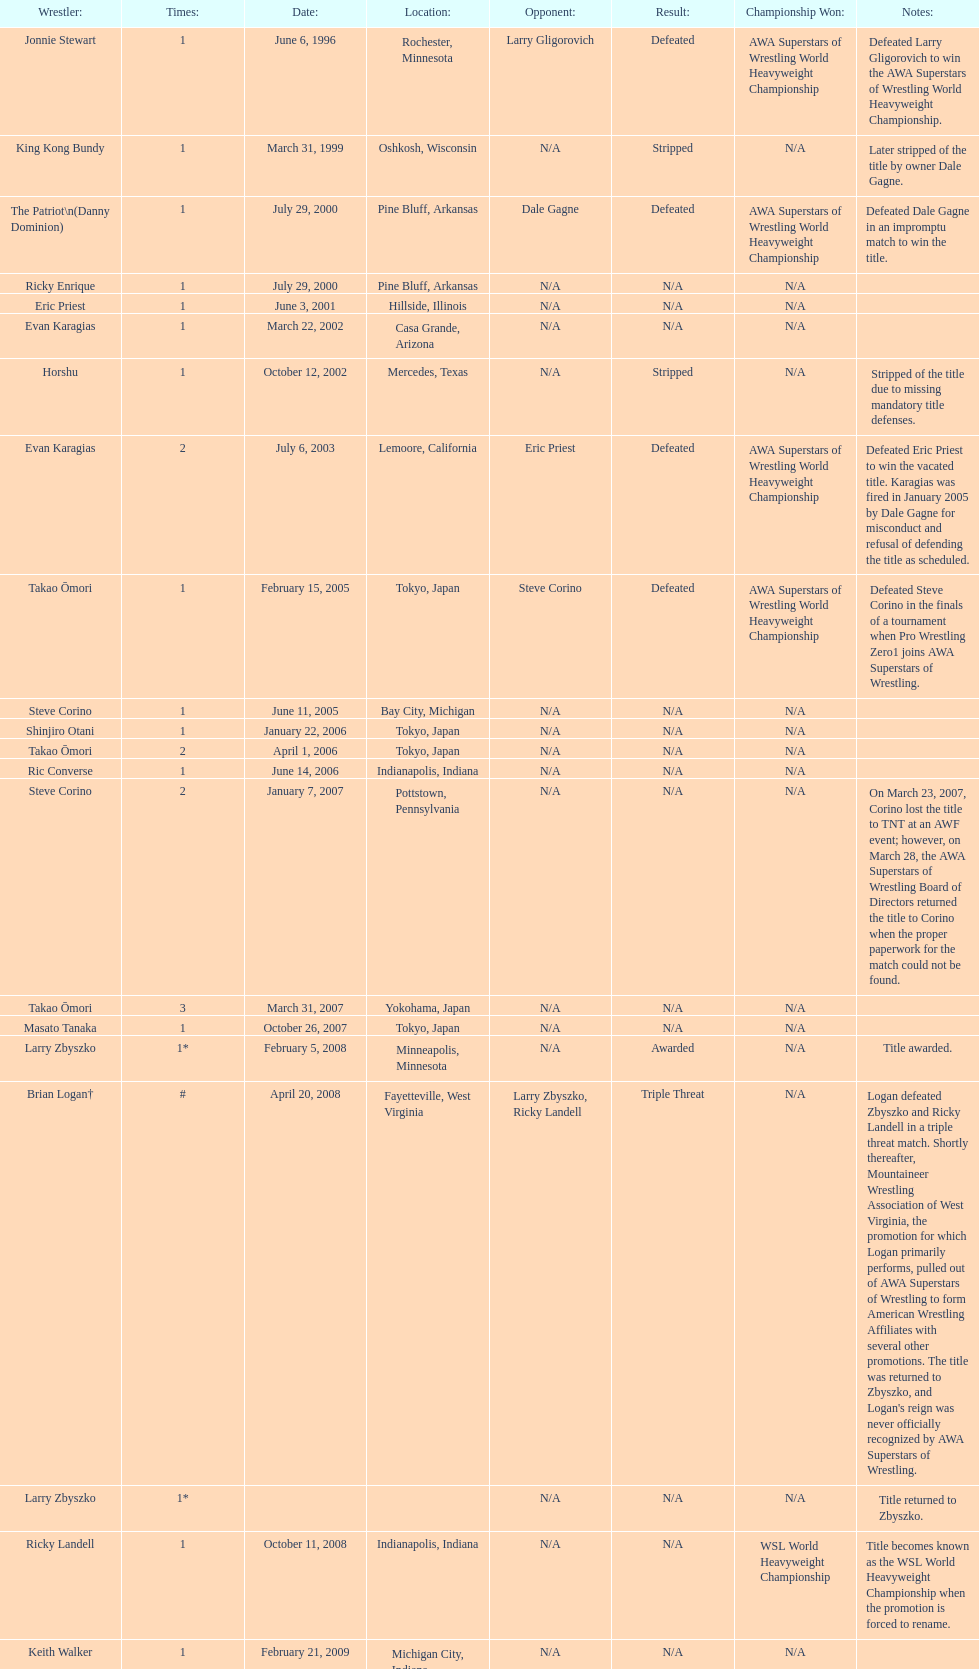Who is the last wrestler to hold the title? The Honky Tonk Man. Give me the full table as a dictionary. {'header': ['Wrestler:', 'Times:', 'Date:', 'Location:', 'Opponent:', 'Result:', 'Championship Won:', 'Notes:'], 'rows': [['Jonnie Stewart', '1', 'June 6, 1996', 'Rochester, Minnesota', 'Larry Gligorovich', 'Defeated', 'AWA Superstars of Wrestling World Heavyweight Championship', 'Defeated Larry Gligorovich to win the AWA Superstars of Wrestling World Heavyweight Championship.'], ['King Kong Bundy', '1', 'March 31, 1999', 'Oshkosh, Wisconsin', 'N/A', 'Stripped', 'N/A', 'Later stripped of the title by owner Dale Gagne.'], ['The Patriot\\n(Danny Dominion)', '1', 'July 29, 2000', 'Pine Bluff, Arkansas', 'Dale Gagne', 'Defeated', 'AWA Superstars of Wrestling World Heavyweight Championship', 'Defeated Dale Gagne in an impromptu match to win the title.'], ['Ricky Enrique', '1', 'July 29, 2000', 'Pine Bluff, Arkansas', 'N/A', 'N/A', 'N/A', ''], ['Eric Priest', '1', 'June 3, 2001', 'Hillside, Illinois', 'N/A', 'N/A', 'N/A', ''], ['Evan Karagias', '1', 'March 22, 2002', 'Casa Grande, Arizona', 'N/A', 'N/A', 'N/A', ''], ['Horshu', '1', 'October 12, 2002', 'Mercedes, Texas', 'N/A', 'Stripped', 'N/A', 'Stripped of the title due to missing mandatory title defenses.'], ['Evan Karagias', '2', 'July 6, 2003', 'Lemoore, California', 'Eric Priest', 'Defeated', 'AWA Superstars of Wrestling World Heavyweight Championship', 'Defeated Eric Priest to win the vacated title. Karagias was fired in January 2005 by Dale Gagne for misconduct and refusal of defending the title as scheduled.'], ['Takao Ōmori', '1', 'February 15, 2005', 'Tokyo, Japan', 'Steve Corino', 'Defeated', 'AWA Superstars of Wrestling World Heavyweight Championship', 'Defeated Steve Corino in the finals of a tournament when Pro Wrestling Zero1 joins AWA Superstars of Wrestling.'], ['Steve Corino', '1', 'June 11, 2005', 'Bay City, Michigan', 'N/A', 'N/A', 'N/A', ''], ['Shinjiro Otani', '1', 'January 22, 2006', 'Tokyo, Japan', 'N/A', 'N/A', 'N/A', ''], ['Takao Ōmori', '2', 'April 1, 2006', 'Tokyo, Japan', 'N/A', 'N/A', 'N/A', ''], ['Ric Converse', '1', 'June 14, 2006', 'Indianapolis, Indiana', 'N/A', 'N/A', 'N/A', ''], ['Steve Corino', '2', 'January 7, 2007', 'Pottstown, Pennsylvania', 'N/A', 'N/A', 'N/A', 'On March 23, 2007, Corino lost the title to TNT at an AWF event; however, on March 28, the AWA Superstars of Wrestling Board of Directors returned the title to Corino when the proper paperwork for the match could not be found.'], ['Takao Ōmori', '3', 'March 31, 2007', 'Yokohama, Japan', 'N/A', 'N/A', 'N/A', ''], ['Masato Tanaka', '1', 'October 26, 2007', 'Tokyo, Japan', 'N/A', 'N/A', 'N/A', ''], ['Larry Zbyszko', '1*', 'February 5, 2008', 'Minneapolis, Minnesota', 'N/A', 'Awarded', 'N/A', 'Title awarded.'], ['Brian Logan†', '#', 'April 20, 2008', 'Fayetteville, West Virginia', 'Larry Zbyszko, Ricky Landell', 'Triple Threat', 'N/A', "Logan defeated Zbyszko and Ricky Landell in a triple threat match. Shortly thereafter, Mountaineer Wrestling Association of West Virginia, the promotion for which Logan primarily performs, pulled out of AWA Superstars of Wrestling to form American Wrestling Affiliates with several other promotions. The title was returned to Zbyszko, and Logan's reign was never officially recognized by AWA Superstars of Wrestling."], ['Larry Zbyszko', '1*', '', '', 'N/A', 'N/A', 'N/A', 'Title returned to Zbyszko.'], ['Ricky Landell', '1', 'October 11, 2008', 'Indianapolis, Indiana', 'N/A', 'N/A', 'WSL World Heavyweight Championship', 'Title becomes known as the WSL World Heavyweight Championship when the promotion is forced to rename.'], ['Keith Walker', '1', 'February 21, 2009', 'Michigan City, Indiana', 'N/A', 'N/A', 'N/A', ''], ['Jonnie Stewart', '2', 'June 9, 2012', 'Landover, Maryland', 'Keith Walker, Ricky Landell', 'Refused', 'AWA Superstars of Wrestling World Heavyweight Championship', "In a day referred to as The Saturday Night Massacre, in reference to President Nixon's firing of two Whitehouse attorneys general in one night; President Dale Gagne strips and fires Keith Walker when Walker refuses to defend the title against Ricky Landell, in an event in Landover, Maryland. When Landell is awarded the title, he refuses to accept and is too promptly fired by Gagne, who than awards the title to Jonnie Stewart."], ['The Honky Tonk Man', '1', 'August 18, 2012', 'Rockford, Illinois', 'Jonnie Stewart', 'Substitute', 'AWA Superstars of Wrestling World Heavyweight Championship', "The morning of the event, Jonnie Stewart's doctors declare him PUP (physically unable to perform) and WSL officials agree to let Mike Bally sub for Stewart."]]} 